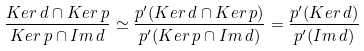<formula> <loc_0><loc_0><loc_500><loc_500>\frac { K e r \, d \cap K e r \, p } { K e r \, p \cap I m \, d } \simeq \frac { p ^ { \prime } ( K e r \, d \cap K e r \, p ) } { p ^ { \prime } ( K e r \, p \cap I m \, d ) } = \frac { p ^ { \prime } ( K e r \, d ) } { p ^ { \prime } ( I m \, d ) }</formula> 